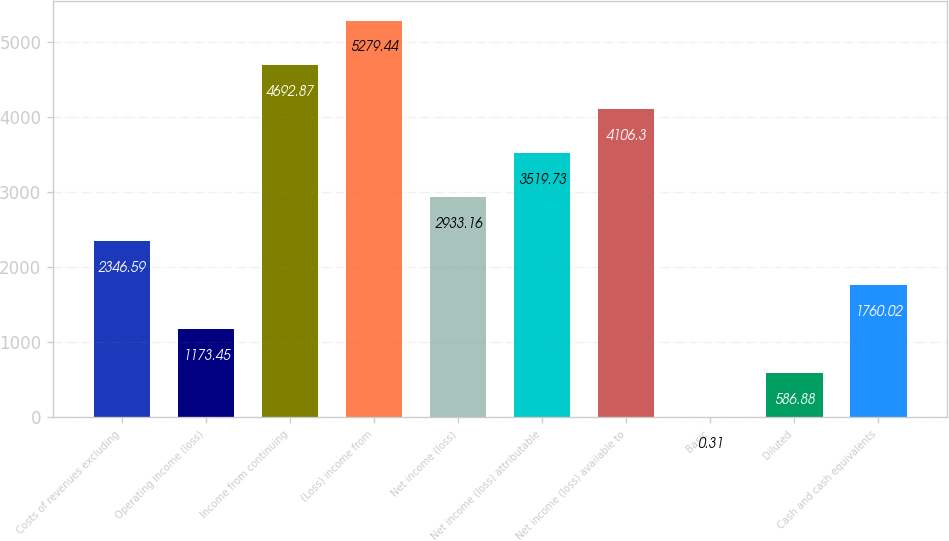<chart> <loc_0><loc_0><loc_500><loc_500><bar_chart><fcel>Costs of revenues excluding<fcel>Operating income (loss)<fcel>Income from continuing<fcel>(Loss) income from<fcel>Net income (loss)<fcel>Net income (loss) attributable<fcel>Net income (loss) available to<fcel>Basic<fcel>Diluted<fcel>Cash and cash equivalents<nl><fcel>2346.59<fcel>1173.45<fcel>4692.87<fcel>5279.44<fcel>2933.16<fcel>3519.73<fcel>4106.3<fcel>0.31<fcel>586.88<fcel>1760.02<nl></chart> 